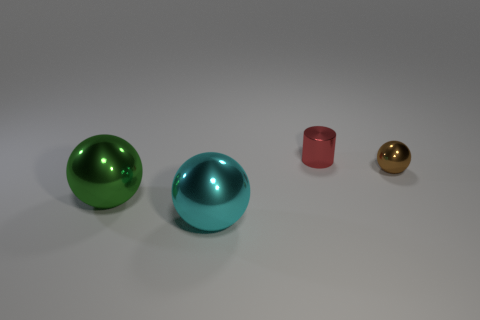Subtract all big metallic balls. How many balls are left? 1 Add 4 large brown metal things. How many objects exist? 8 Subtract all blue spheres. Subtract all green cylinders. How many spheres are left? 3 Add 4 large metallic things. How many large metallic things are left? 6 Add 4 small metal spheres. How many small metal spheres exist? 5 Subtract 0 blue cubes. How many objects are left? 4 Subtract all balls. How many objects are left? 1 Subtract all big blocks. Subtract all small objects. How many objects are left? 2 